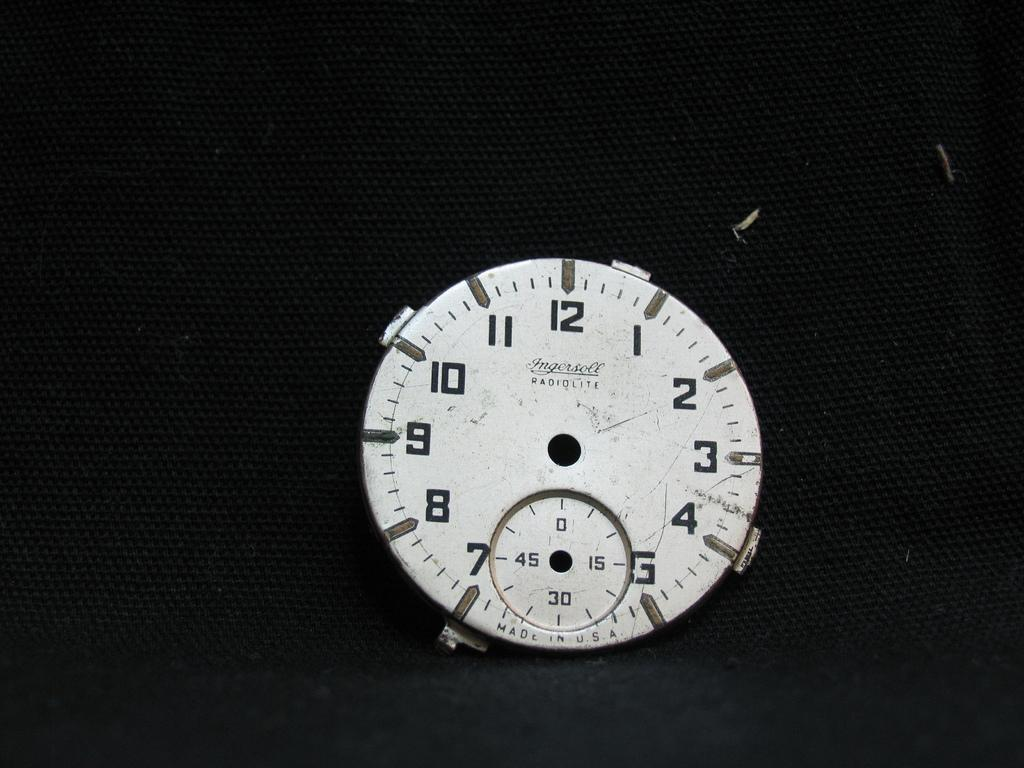<image>
Describe the image concisely. the dial of an Ingersoll watch with no hands 